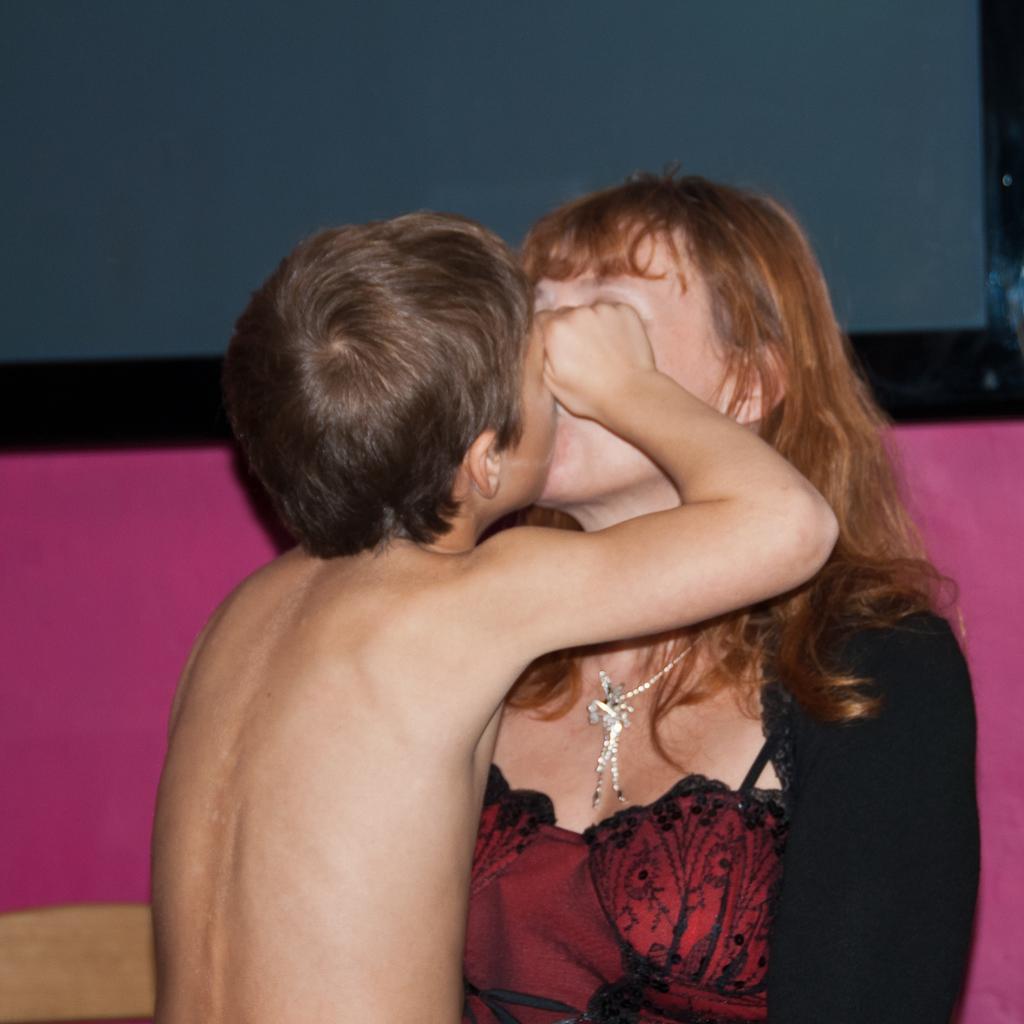Can you describe this image briefly? In this picture we can see a boy kissing a woman. We can see a pink color object and blue color object in the background. 